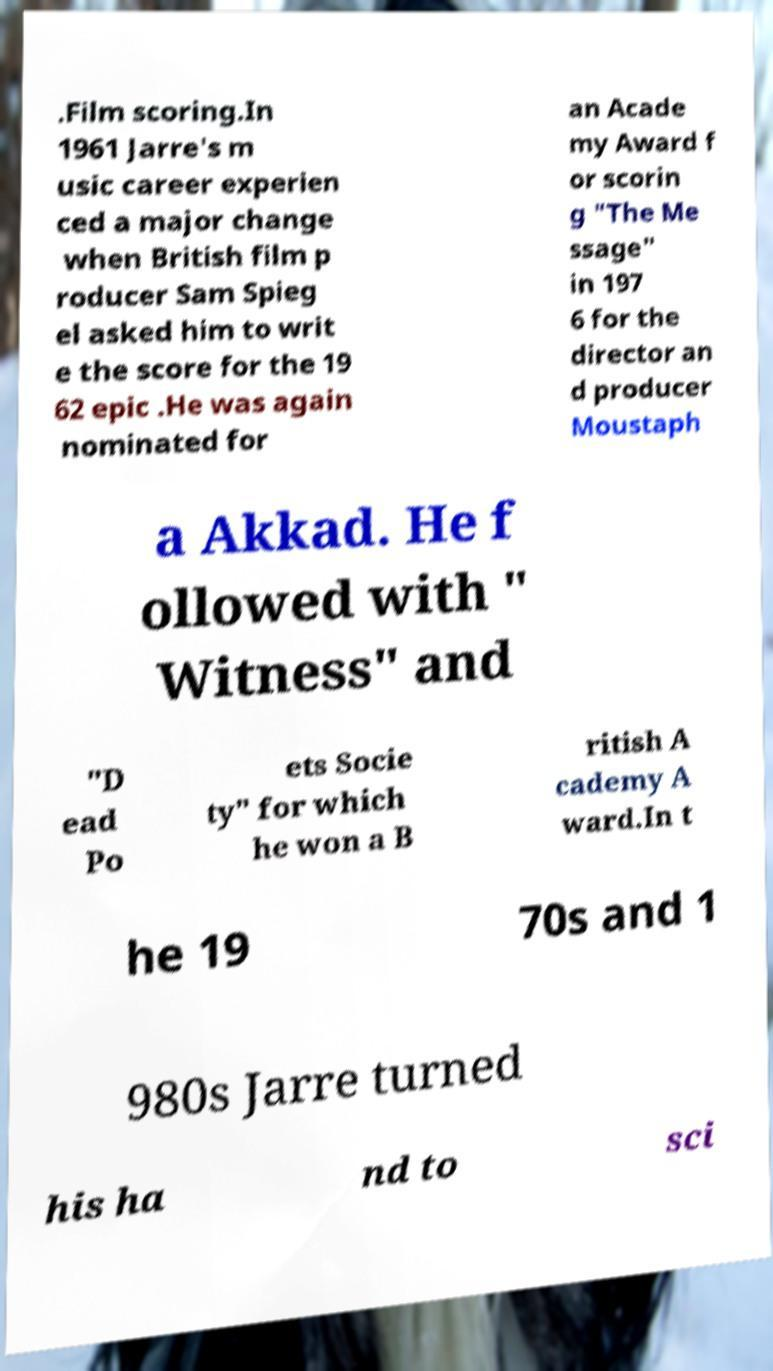What messages or text are displayed in this image? I need them in a readable, typed format. .Film scoring.In 1961 Jarre's m usic career experien ced a major change when British film p roducer Sam Spieg el asked him to writ e the score for the 19 62 epic .He was again nominated for an Acade my Award f or scorin g "The Me ssage" in 197 6 for the director an d producer Moustaph a Akkad. He f ollowed with " Witness" and "D ead Po ets Socie ty" for which he won a B ritish A cademy A ward.In t he 19 70s and 1 980s Jarre turned his ha nd to sci 